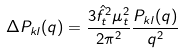<formula> <loc_0><loc_0><loc_500><loc_500>\Delta P _ { k l } ( q ) = \frac { 3 \hat { f } ^ { 2 } _ { t } \mu ^ { 2 } _ { t } } { 2 \pi ^ { 2 } } \frac { P _ { k l } ( q ) } { q ^ { 2 } }</formula> 